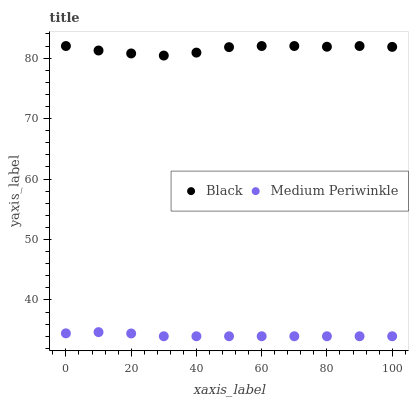Does Medium Periwinkle have the minimum area under the curve?
Answer yes or no. Yes. Does Black have the maximum area under the curve?
Answer yes or no. Yes. Does Black have the minimum area under the curve?
Answer yes or no. No. Is Medium Periwinkle the smoothest?
Answer yes or no. Yes. Is Black the roughest?
Answer yes or no. Yes. Is Black the smoothest?
Answer yes or no. No. Does Medium Periwinkle have the lowest value?
Answer yes or no. Yes. Does Black have the lowest value?
Answer yes or no. No. Does Black have the highest value?
Answer yes or no. Yes. Is Medium Periwinkle less than Black?
Answer yes or no. Yes. Is Black greater than Medium Periwinkle?
Answer yes or no. Yes. Does Medium Periwinkle intersect Black?
Answer yes or no. No. 